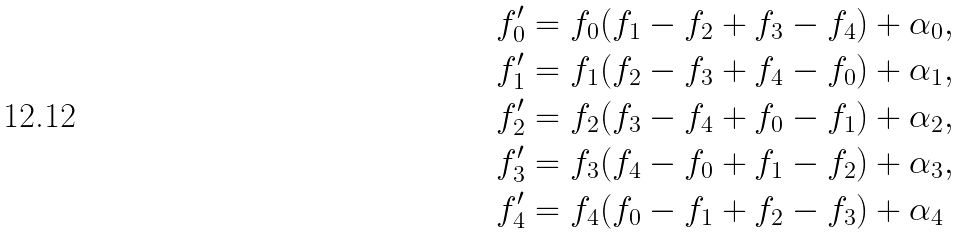Convert formula to latex. <formula><loc_0><loc_0><loc_500><loc_500>& f ^ { \prime } _ { 0 } = f _ { 0 } ( f _ { 1 } - f _ { 2 } + f _ { 3 } - f _ { 4 } ) + \alpha _ { 0 } , \\ & f ^ { \prime } _ { 1 } = f _ { 1 } ( f _ { 2 } - f _ { 3 } + f _ { 4 } - f _ { 0 } ) + \alpha _ { 1 } , \\ & f ^ { \prime } _ { 2 } = f _ { 2 } ( f _ { 3 } - f _ { 4 } + f _ { 0 } - f _ { 1 } ) + \alpha _ { 2 } , \\ & f ^ { \prime } _ { 3 } = f _ { 3 } ( f _ { 4 } - f _ { 0 } + f _ { 1 } - f _ { 2 } ) + \alpha _ { 3 } , \\ & f ^ { \prime } _ { 4 } = f _ { 4 } ( f _ { 0 } - f _ { 1 } + f _ { 2 } - f _ { 3 } ) + \alpha _ { 4 }</formula> 